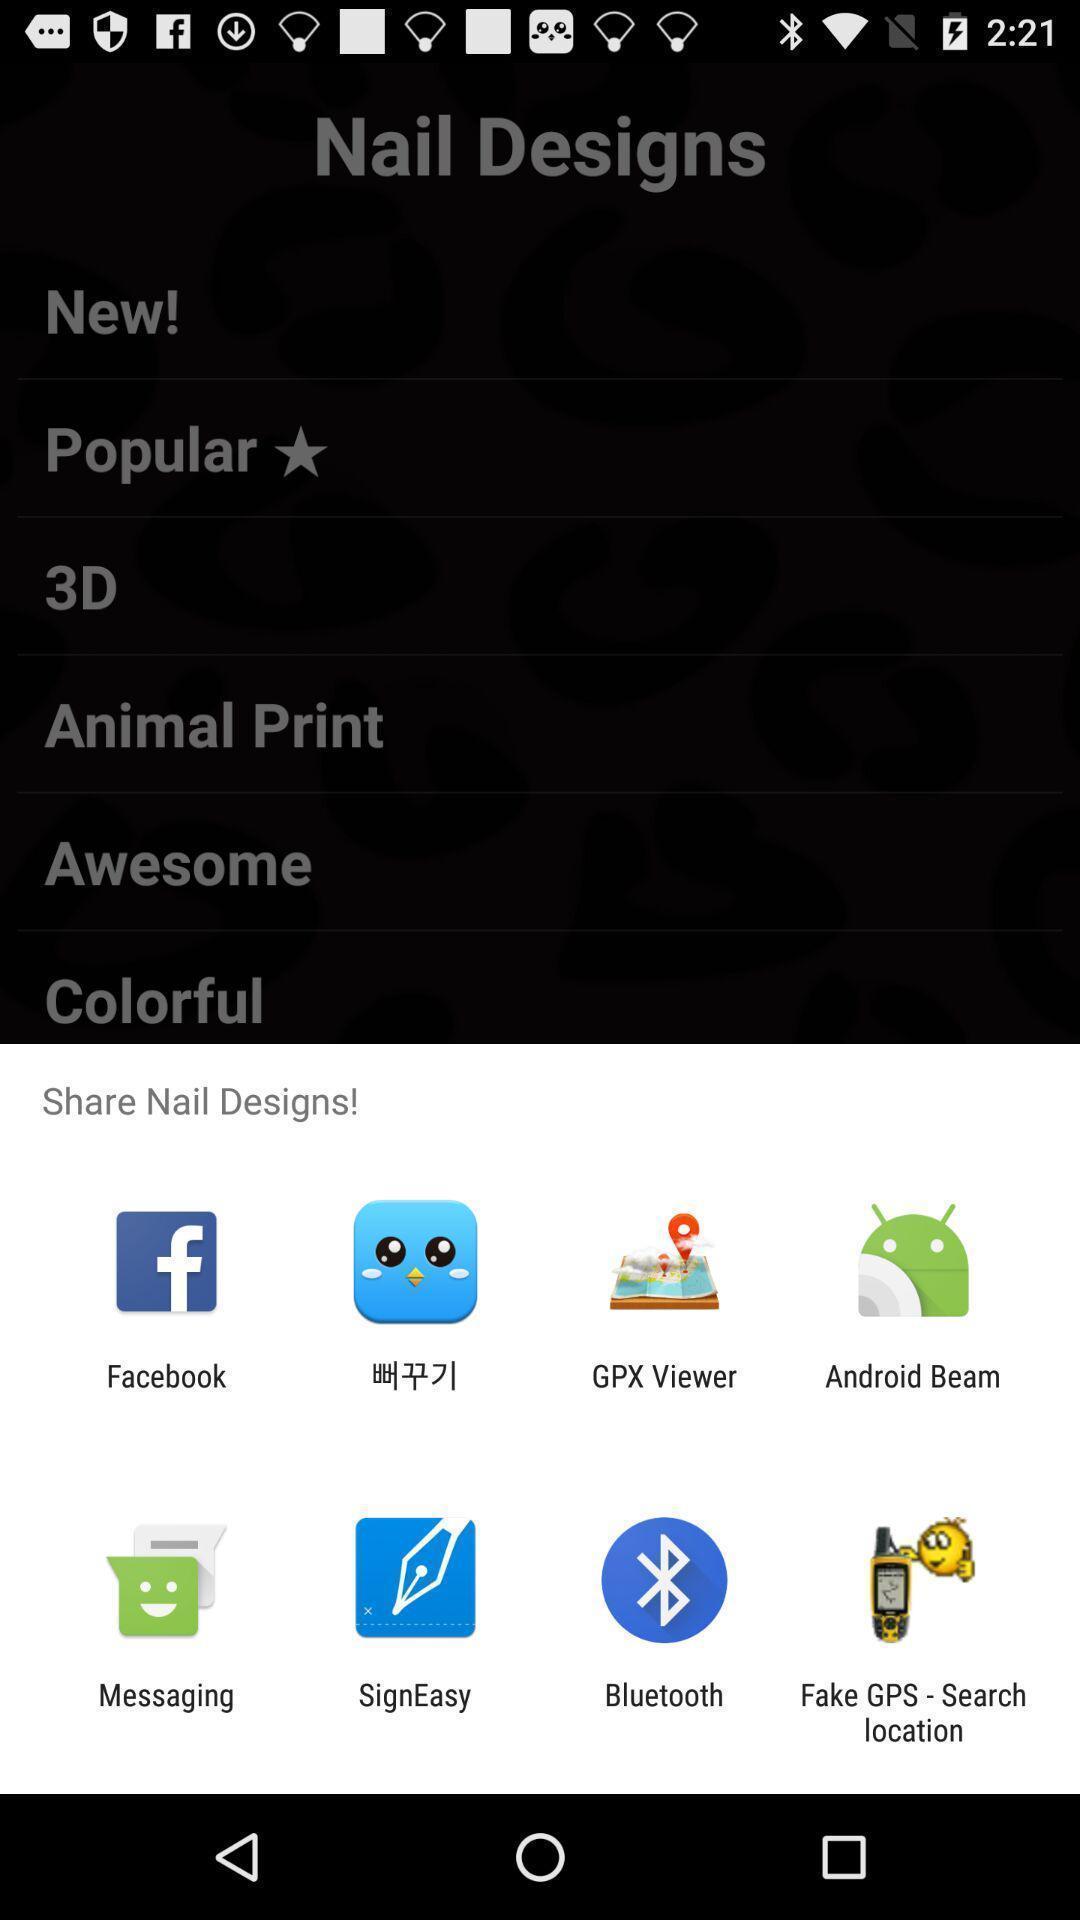Describe the key features of this screenshot. Pop-up shows share nail designs with multiple applications. 